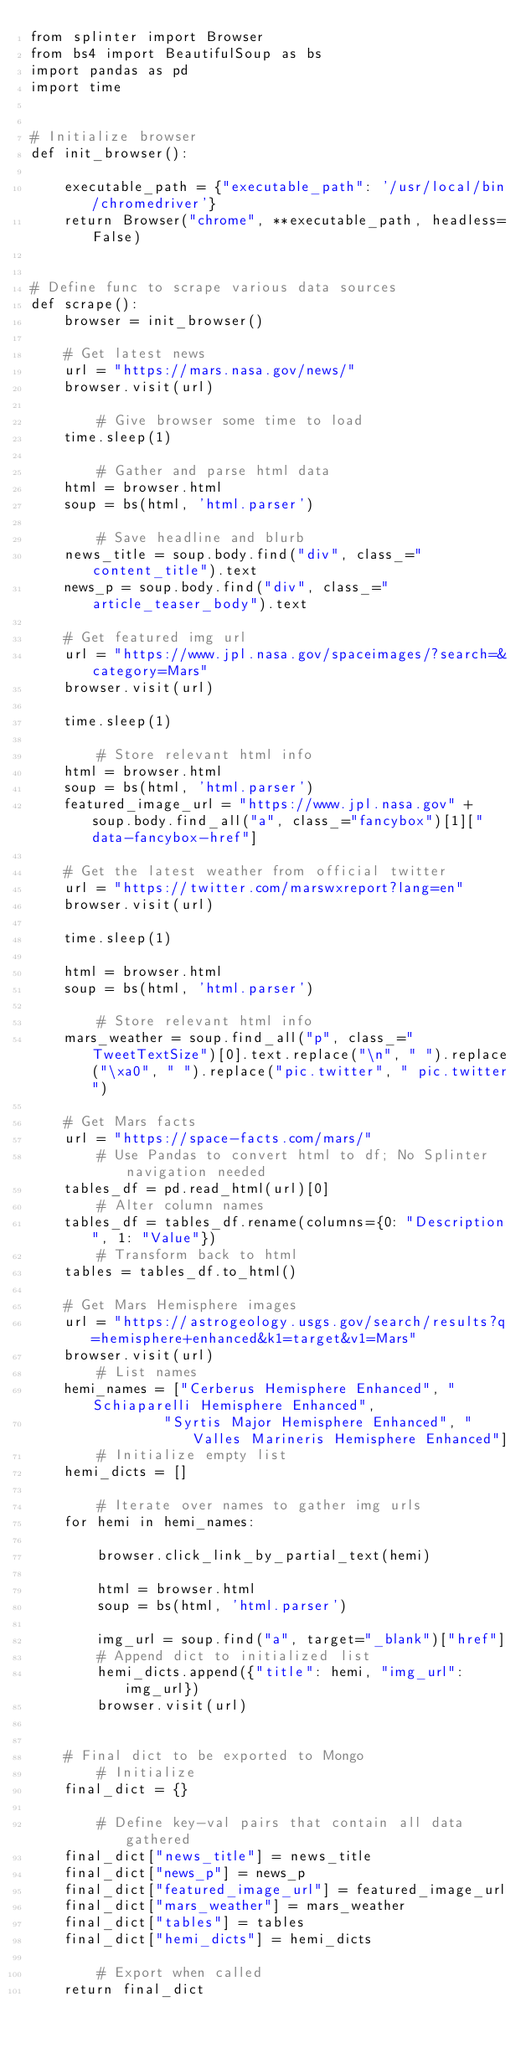Convert code to text. <code><loc_0><loc_0><loc_500><loc_500><_Python_>from splinter import Browser
from bs4 import BeautifulSoup as bs
import pandas as pd
import time


# Initialize browser
def init_browser():

    executable_path = {"executable_path": '/usr/local/bin/chromedriver'}
    return Browser("chrome", **executable_path, headless=False)


# Define func to scrape various data sources
def scrape():
    browser = init_browser()

    # Get latest news
    url = "https://mars.nasa.gov/news/"
    browser.visit(url)

        # Give browser some time to load
    time.sleep(1)

        # Gather and parse html data
    html = browser.html
    soup = bs(html, 'html.parser')

        # Save headline and blurb
    news_title = soup.body.find("div", class_="content_title").text
    news_p = soup.body.find("div", class_="article_teaser_body").text

    # Get featured img url
    url = "https://www.jpl.nasa.gov/spaceimages/?search=&category=Mars"
    browser.visit(url)    
    
    time.sleep(1)

        # Store relevant html info
    html = browser.html
    soup = bs(html, 'html.parser')
    featured_image_url = "https://www.jpl.nasa.gov" + soup.body.find_all("a", class_="fancybox")[1]["data-fancybox-href"]

    # Get the latest weather from official twitter
    url = "https://twitter.com/marswxreport?lang=en"
    browser.visit(url)

    time.sleep(1)

    html = browser.html
    soup = bs(html, 'html.parser')

        # Store relevant html info
    mars_weather = soup.find_all("p", class_="TweetTextSize")[0].text.replace("\n", " ").replace("\xa0", " ").replace("pic.twitter", " pic.twitter")

    # Get Mars facts
    url = "https://space-facts.com/mars/"
        # Use Pandas to convert html to df; No Splinter navigation needed
    tables_df = pd.read_html(url)[0]
        # Alter column names
    tables_df = tables_df.rename(columns={0: "Description", 1: "Value"})
        # Transform back to html
    tables = tables_df.to_html()
    
    # Get Mars Hemisphere images
    url = "https://astrogeology.usgs.gov/search/results?q=hemisphere+enhanced&k1=target&v1=Mars"
    browser.visit(url)
        # List names
    hemi_names = ["Cerberus Hemisphere Enhanced", "Schiaparelli Hemisphere Enhanced",
                "Syrtis Major Hemisphere Enhanced", "Valles Marineris Hemisphere Enhanced"]
        # Initialize empty list
    hemi_dicts = []

        # Iterate over names to gather img urls
    for hemi in hemi_names:

        browser.click_link_by_partial_text(hemi)

        html = browser.html
        soup = bs(html, 'html.parser')

        img_url = soup.find("a", target="_blank")["href"]
        # Append dict to initialized list
        hemi_dicts.append({"title": hemi, "img_url": img_url})
        browser.visit(url)


    # Final dict to be exported to Mongo
        # Initialize
    final_dict = {}

        # Define key-val pairs that contain all data gathered
    final_dict["news_title"] = news_title
    final_dict["news_p"] = news_p
    final_dict["featured_image_url"] = featured_image_url
    final_dict["mars_weather"] = mars_weather
    final_dict["tables"] = tables
    final_dict["hemi_dicts"] = hemi_dicts

        # Export when called
    return final_dict



</code> 